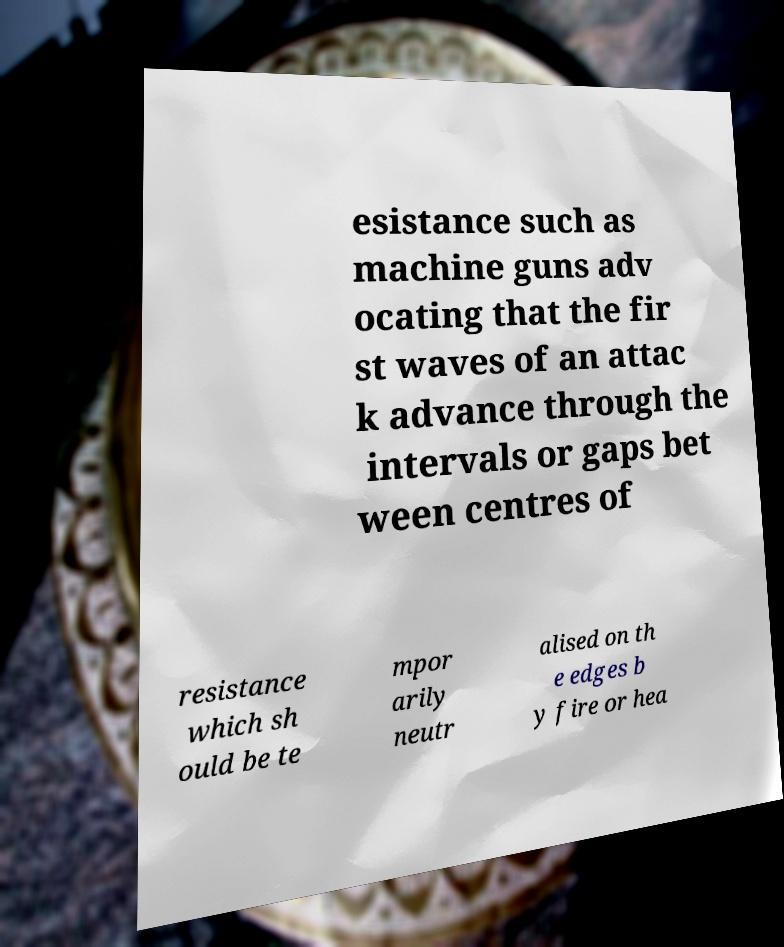Please identify and transcribe the text found in this image. esistance such as machine guns adv ocating that the fir st waves of an attac k advance through the intervals or gaps bet ween centres of resistance which sh ould be te mpor arily neutr alised on th e edges b y fire or hea 